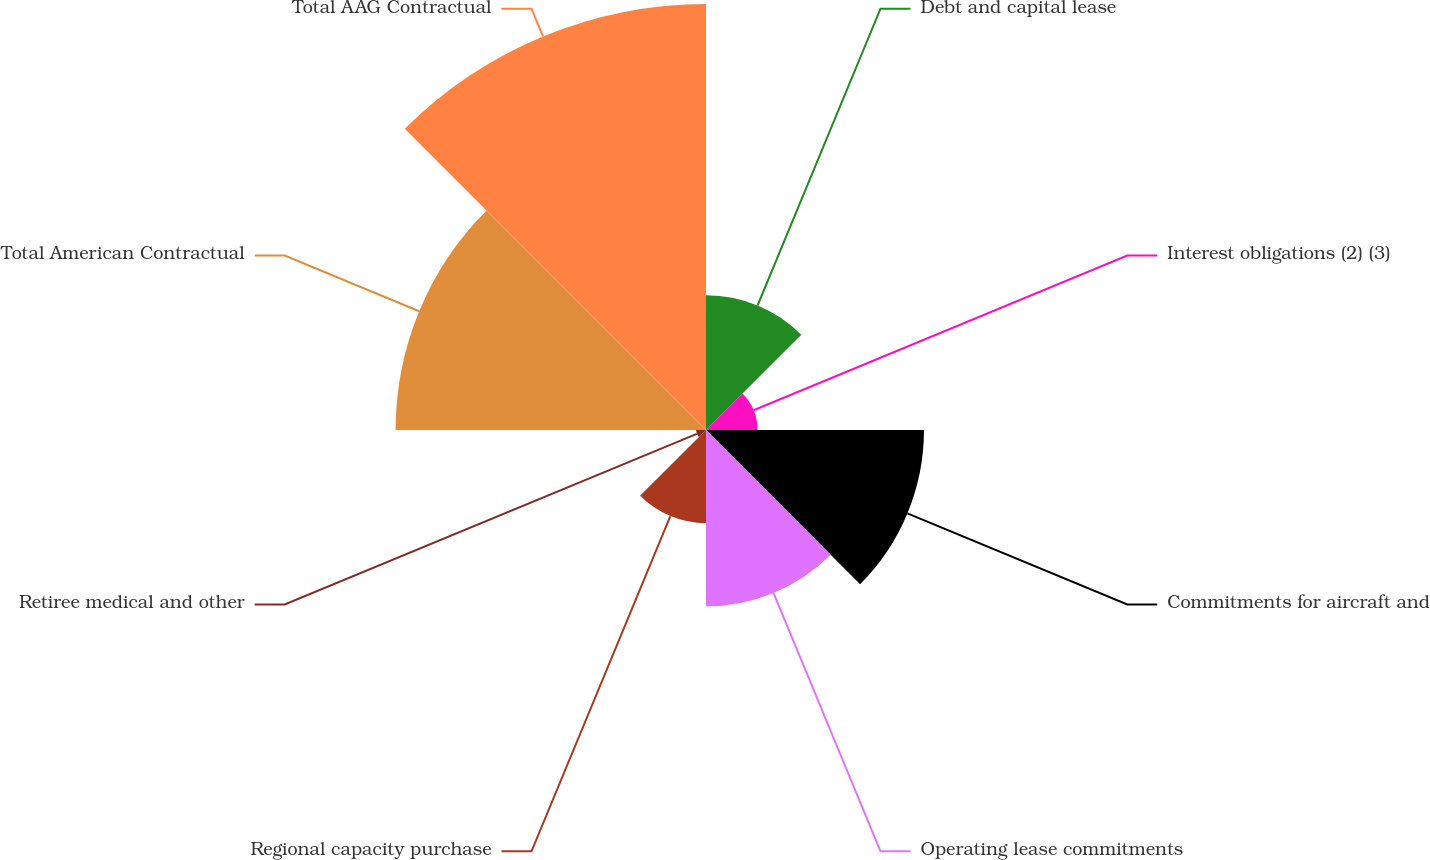<chart> <loc_0><loc_0><loc_500><loc_500><pie_chart><fcel>Debt and capital lease<fcel>Interest obligations (2) (3)<fcel>Commitments for aircraft and<fcel>Operating lease commitments<fcel>Regional capacity purchase<fcel>Retiree medical and other<fcel>Total American Contractual<fcel>Total AAG Contractual<nl><fcel>9.49%<fcel>3.63%<fcel>15.35%<fcel>12.42%<fcel>6.56%<fcel>0.7%<fcel>21.86%<fcel>30.0%<nl></chart> 